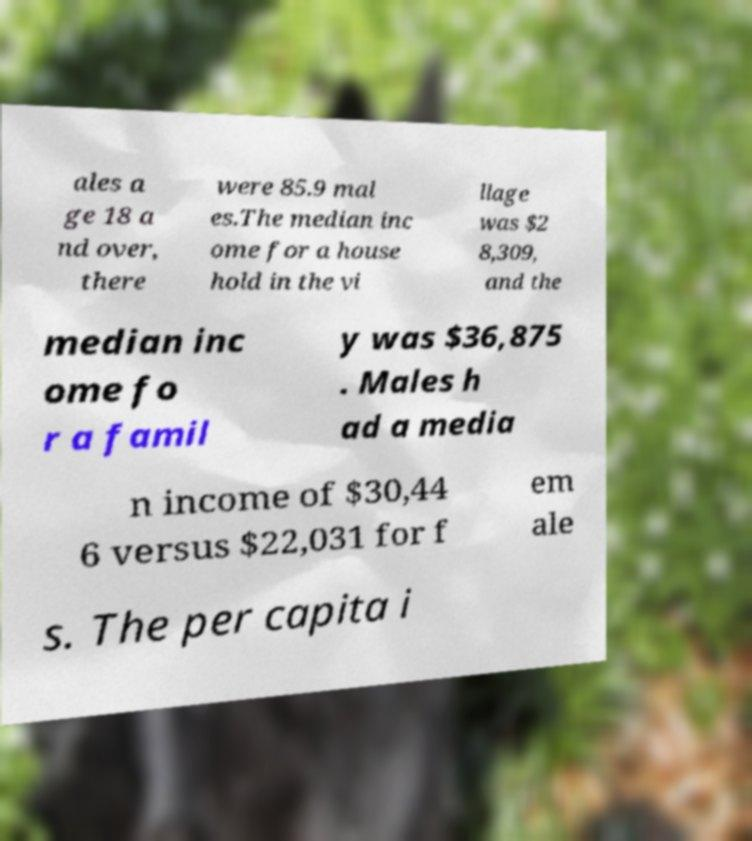Please identify and transcribe the text found in this image. ales a ge 18 a nd over, there were 85.9 mal es.The median inc ome for a house hold in the vi llage was $2 8,309, and the median inc ome fo r a famil y was $36,875 . Males h ad a media n income of $30,44 6 versus $22,031 for f em ale s. The per capita i 